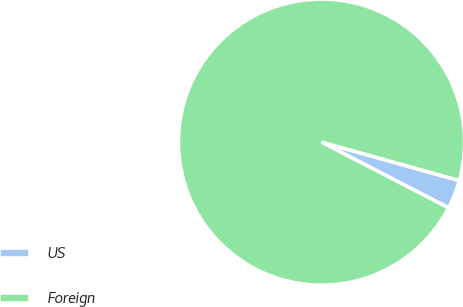<chart> <loc_0><loc_0><loc_500><loc_500><pie_chart><fcel>US<fcel>Foreign<nl><fcel>3.27%<fcel>96.73%<nl></chart> 